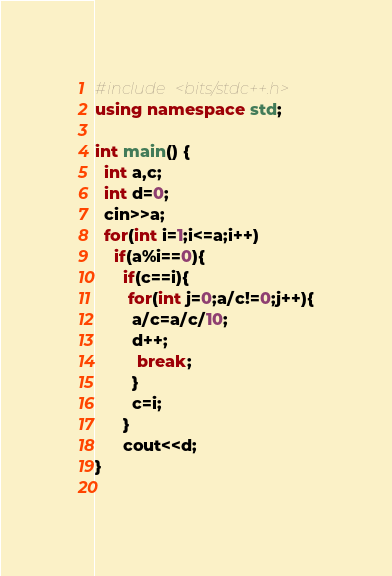Convert code to text. <code><loc_0><loc_0><loc_500><loc_500><_C++_>#include <bits/stdc++.h>
using namespace std;
 
int main() {
  int a,c;
  int d=0;
  cin>>a;
  for(int i=1;i<=a;i++)
    if(a%i==0){
      if(c==i){
       for(int j=0;a/c!=0;j++){
        a/c=a/c/10;
        d++;
         break;
        }
        c=i;
      }
      cout<<d;
}
  </code> 